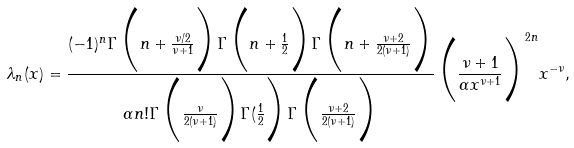<formula> <loc_0><loc_0><loc_500><loc_500>\lambda _ { n } ( x ) = \frac { ( - 1 ) ^ { n } \Gamma \Big ( n + \frac { \nu / 2 } { \nu + 1 } \Big ) \Gamma \Big ( n + \frac { 1 } { 2 } \Big ) \Gamma \Big ( n + \frac { \nu + 2 } { 2 ( \nu + 1 ) } \Big ) } { \alpha n ! \Gamma \Big ( \frac { \nu } { 2 ( \nu + 1 ) } \Big ) \Gamma ( \frac { 1 } { 2 } \Big ) \Gamma \Big ( \frac { \nu + 2 } { 2 ( \nu + 1 ) } \Big ) } \Big ( \frac { \nu + 1 } { \alpha x ^ { \nu + 1 } } \Big ) ^ { 2 n } x ^ { - \nu } ,</formula> 